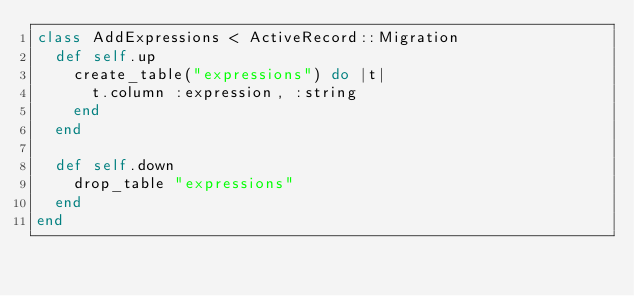Convert code to text. <code><loc_0><loc_0><loc_500><loc_500><_Ruby_>class AddExpressions < ActiveRecord::Migration
  def self.up
    create_table("expressions") do |t|
      t.column :expression, :string
    end
  end

  def self.down
    drop_table "expressions"
  end
end
</code> 